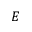Convert formula to latex. <formula><loc_0><loc_0><loc_500><loc_500>E</formula> 